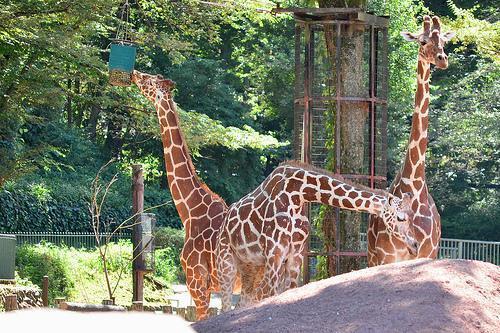How many giraffes are there?
Give a very brief answer. 3. How many giraffes are eating?
Give a very brief answer. 1. 